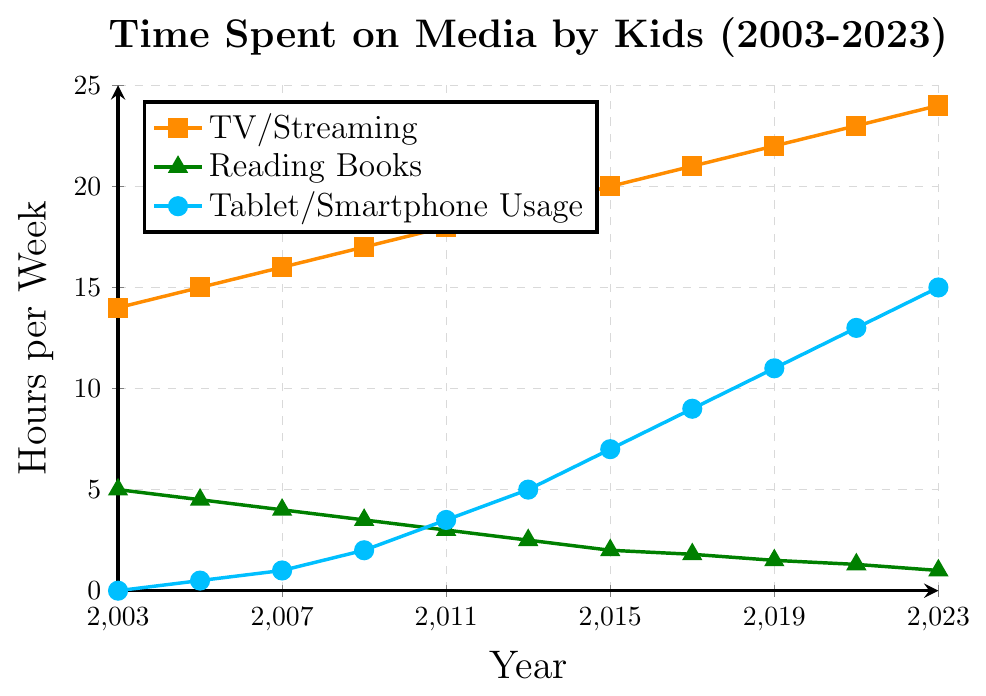What's the overall trend of TV/Streaming usage from 2003 to 2023? From 2003 to 2023, the time spent on TV/Streaming consistently increased, starting from 14 hours/week in 2003 and rising to 24 hours/week in 2023.
Answer: Increasing How much did reading books decrease from 2003 to 2023? In 2003, the time spent reading books was 5 hours/week, and in 2023, it was 1 hour/week. The decrease is 5 - 1 = 4 hours/week.
Answer: 4 hours/week In what year did Tablet/Smartphone usage surpass TV/Streaming usage? Tablet/Smartphone usage never surpassed TV/Streaming usage in the time period from 2003 to 2023. At each point in the interval, TV/Streaming usage was higher.
Answer: Never Compare the rate of increase between Tablet/Smartphone usage and TV/Streaming. Which one increased more rapidly between 2011 and 2023? Tablet/Smartphone usage went from 3.5 hours/week in 2011 to 15 hours/week in 2023. TV/Streaming usage went from 18 hours/week in 2011 to 24 hours/week in 2023. The increase for Tablet/Smartphone is 15 - 3.5 = 11.5 hours/week, and for TV/Streaming, it is 24 - 18 = 6 hours/week. Tablet/Smartphone increased more rapidly.
Answer: Tablet/Smartphone What is the difference between TV/Streaming usage and Reading Books in 2023? In 2023, TV/Streaming usage is 24 hours/week, and Reading Books is 1 hour/week. The difference is 24 - 1 = 23 hours/week.
Answer: 23 hours/week How many hours more per week did kids spend on Tablet/Smartphone usage compared to reading books in 2017? In 2017, Tablet/Smartphone usage was 9 hours/week, and Reading Books was 1.8 hours/week. The difference is 9 - 1.8 = 7.2 hours/week.
Answer: 7.2 hours/week Which activity had the smallest increase over the 20 years? Reading Books decreased over the 20 years from 5 hours/week to 1 hour/week, which is a decrease rather than an increase. Both TV/Streaming and Tablet/Smartphone usage increased, with TV/Streaming increasing by 10 hours/week and Tablet/Smartphone usage increasing by 15 hours/week.
Answer: Reading Books What can you say about the visual attributes (color and shape) of the lines representing TV/Streaming, Reading Books, and Tablet/Smartphone Usage in the chart? The line for TV/Streaming usage is orange with square markers, the line for Reading Books is green with triangle markers, and the line for Tablet/Smartphone usage is blue with circular markers.
Answer: Orange squares, Green triangles, Blue circles When did Tablet/Smartphone usage first surpass Reading Books? In 2009, Tablet/Smartphone usage was 2 hours/week while Reading Books was 3.5 hours/week. In 2011, Tablet/Smartphone usage was 3.5 hours/week, equal to Reading Books. In 2013, Tablet/Smartphone usage was 5 hours/week, compared to Reading Books at 2.5 hours/week. Therefore, it first surpassed Reading Books in 2013.
Answer: 2013 